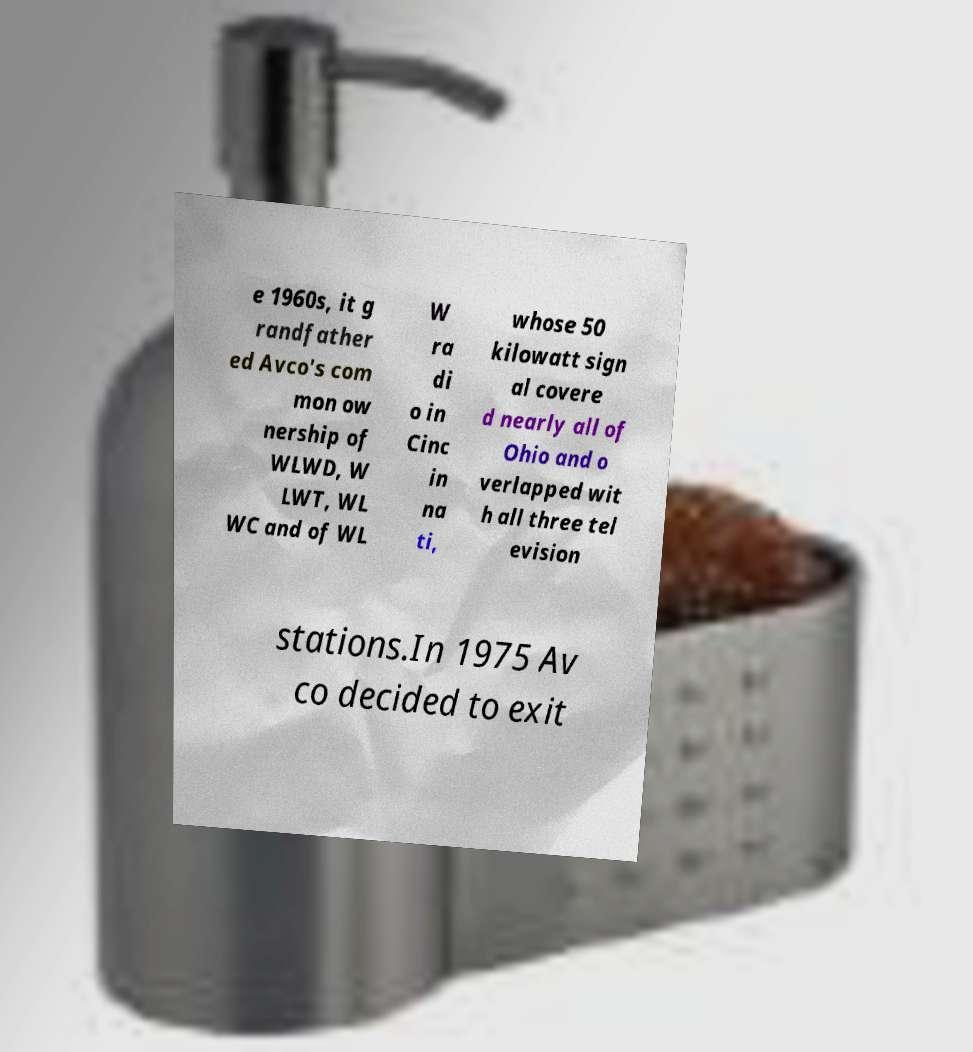Could you extract and type out the text from this image? e 1960s, it g randfather ed Avco's com mon ow nership of WLWD, W LWT, WL WC and of WL W ra di o in Cinc in na ti, whose 50 kilowatt sign al covere d nearly all of Ohio and o verlapped wit h all three tel evision stations.In 1975 Av co decided to exit 